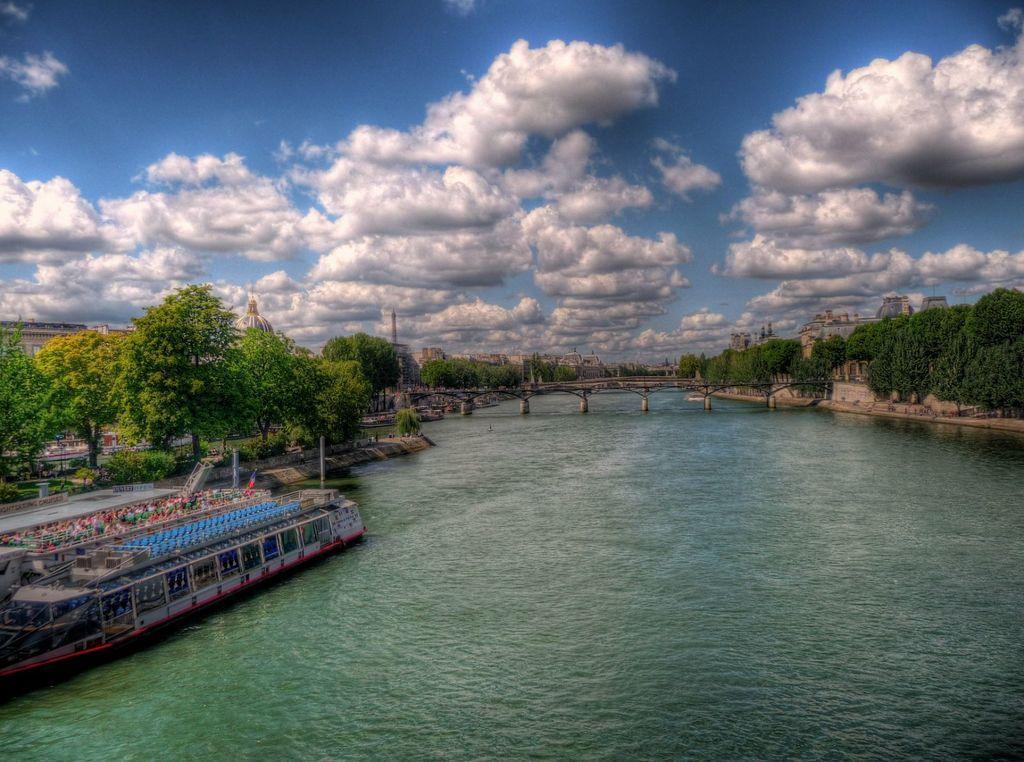In one or two sentences, can you explain what this image depicts? In this image there is the sky towards the top of the image, there are clouds in the sky, there are buildings, there are trees, there is water towards the bottom of the image, there is a boat towards the left of the image, there is a bridged, there are plants towards the left of the image. 